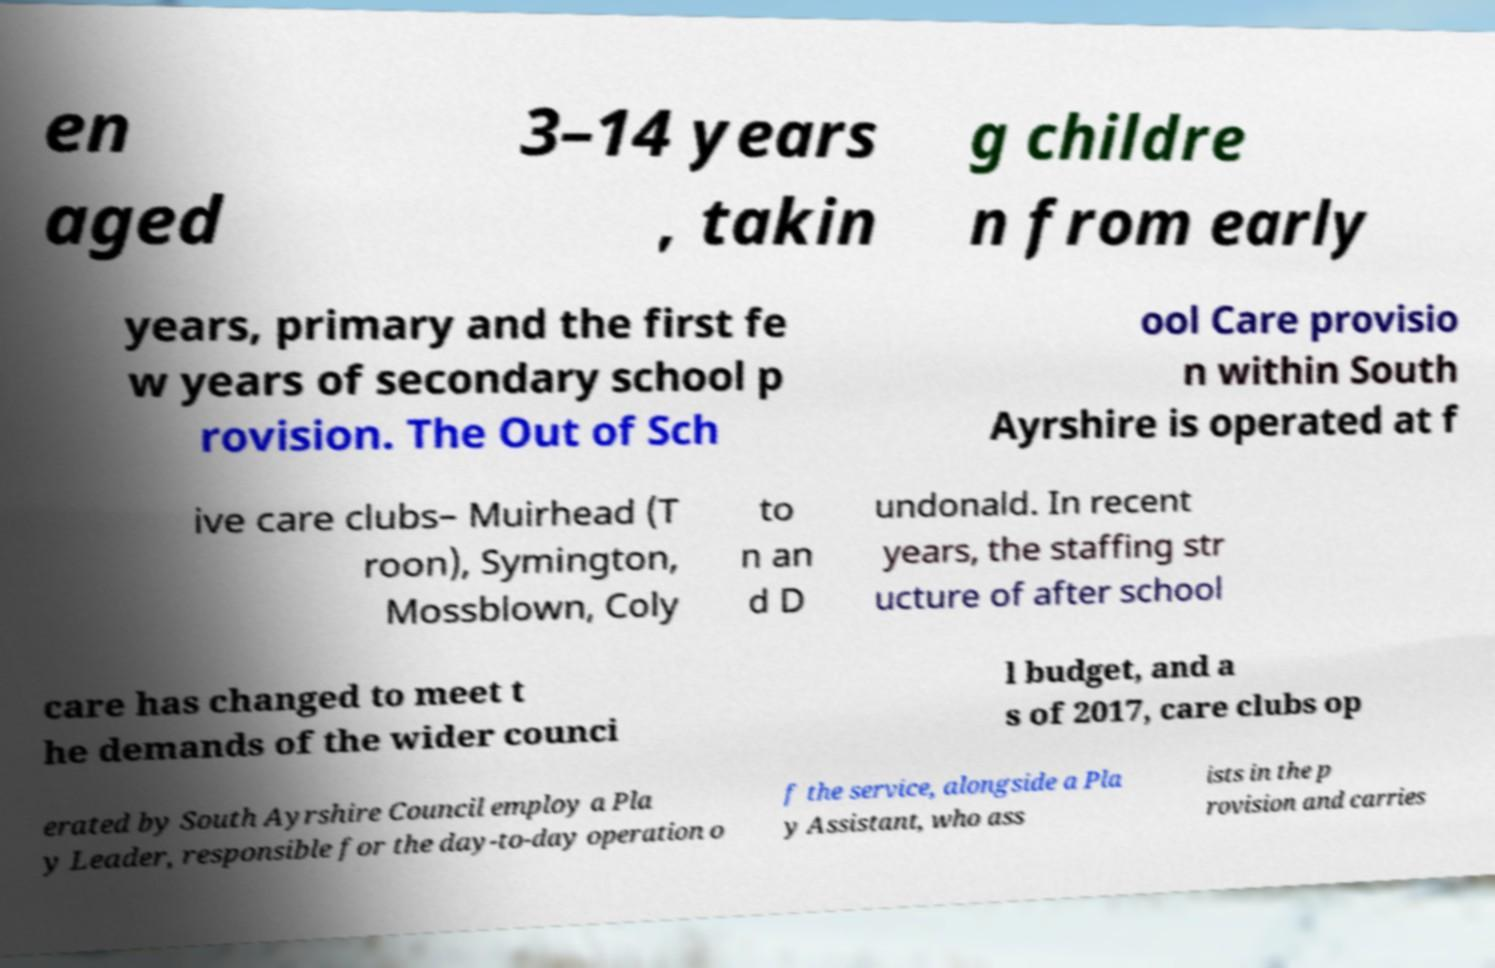Can you read and provide the text displayed in the image?This photo seems to have some interesting text. Can you extract and type it out for me? en aged 3–14 years , takin g childre n from early years, primary and the first fe w years of secondary school p rovision. The Out of Sch ool Care provisio n within South Ayrshire is operated at f ive care clubs– Muirhead (T roon), Symington, Mossblown, Coly to n an d D undonald. In recent years, the staffing str ucture of after school care has changed to meet t he demands of the wider counci l budget, and a s of 2017, care clubs op erated by South Ayrshire Council employ a Pla y Leader, responsible for the day-to-day operation o f the service, alongside a Pla y Assistant, who ass ists in the p rovision and carries 